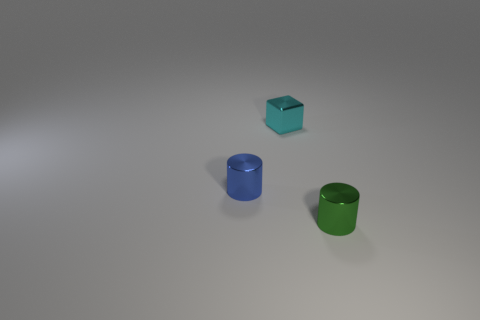Add 3 tiny purple metal cubes. How many objects exist? 6 Subtract 1 cylinders. How many cylinders are left? 1 Subtract all blue balls. How many gray cubes are left? 0 Add 1 small metal things. How many small metal things are left? 4 Add 3 big red matte objects. How many big red matte objects exist? 3 Subtract 0 red cubes. How many objects are left? 3 Subtract all cubes. How many objects are left? 2 Subtract all purple cylinders. Subtract all green blocks. How many cylinders are left? 2 Subtract all big spheres. Subtract all blue metallic cylinders. How many objects are left? 2 